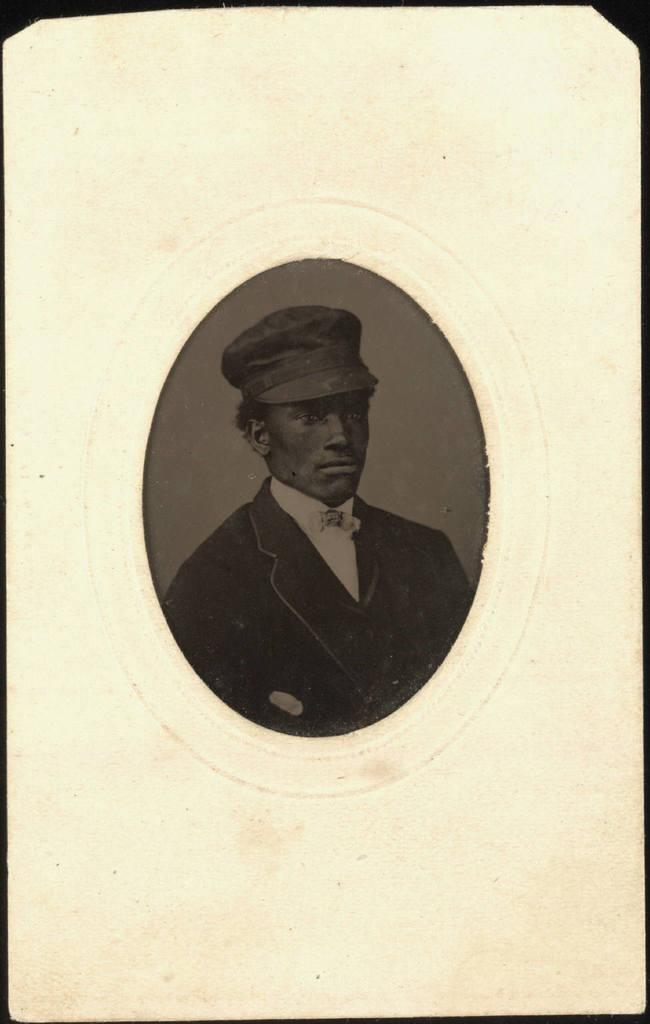What type of visual medium is the image? The image appears to be a poster. What is the main subject in the foreground of the poster? There is a depiction of a person in the foreground of the poster. How would you describe the background of the poster? The background of the poster is colored. What is the size of the person depicted in the poster? The size of the person depicted in the poster cannot be determined from the image alone, as it is a 2D representation and does not provide a sense of scale. 